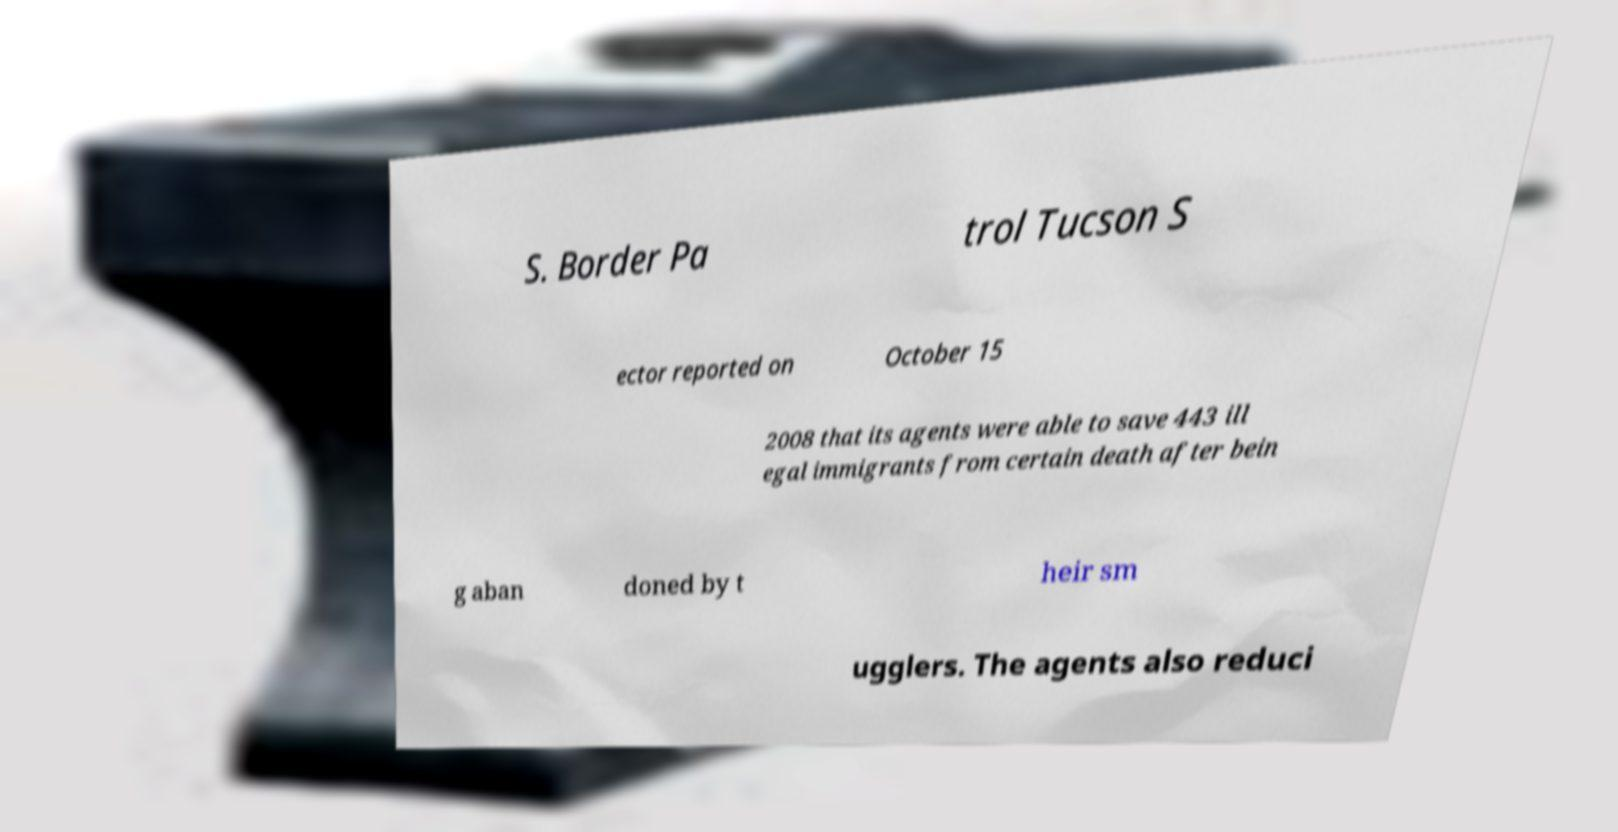Can you accurately transcribe the text from the provided image for me? S. Border Pa trol Tucson S ector reported on October 15 2008 that its agents were able to save 443 ill egal immigrants from certain death after bein g aban doned by t heir sm ugglers. The agents also reduci 